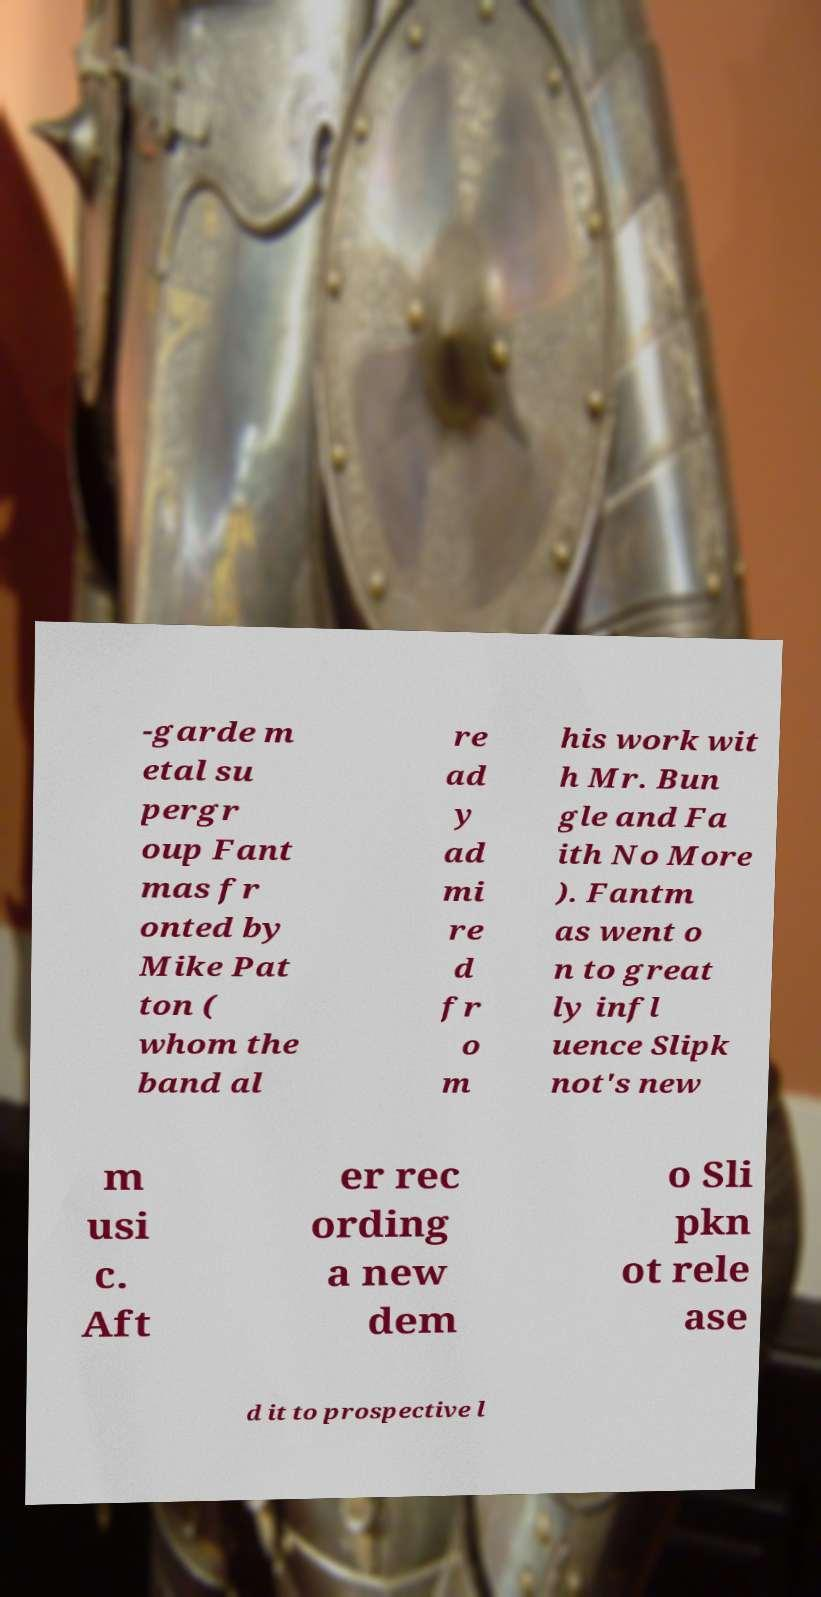Please read and relay the text visible in this image. What does it say? -garde m etal su pergr oup Fant mas fr onted by Mike Pat ton ( whom the band al re ad y ad mi re d fr o m his work wit h Mr. Bun gle and Fa ith No More ). Fantm as went o n to great ly infl uence Slipk not's new m usi c. Aft er rec ording a new dem o Sli pkn ot rele ase d it to prospective l 